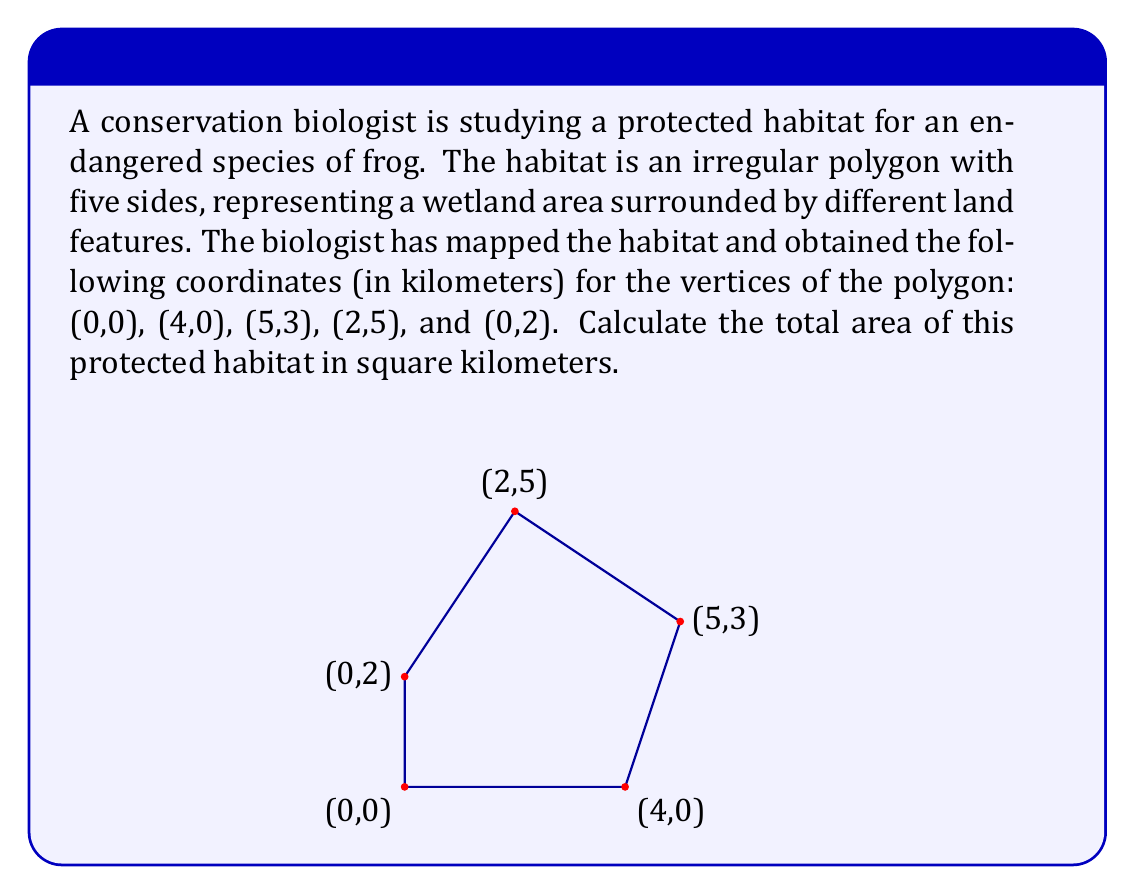What is the answer to this math problem? To calculate the area of this irregular polygon, we can use the Shoelace formula (also known as the surveyor's formula). This method is particularly useful for calculating the area of any polygon given the coordinates of its vertices.

The Shoelace formula is:

$$ A = \frac{1}{2}|\sum_{i=1}^{n-1} (x_iy_{i+1} + x_ny_1) - \sum_{i=1}^{n-1} (y_ix_{i+1} + y_nx_1)| $$

Where $(x_i, y_i)$ are the coordinates of the $i$-th vertex, and $n$ is the number of vertices.

Let's apply this formula to our polygon:

1) First, let's list our coordinates in order:
   $(x_1, y_1) = (0, 0)$
   $(x_2, y_2) = (4, 0)$
   $(x_3, y_3) = (5, 3)$
   $(x_4, y_4) = (2, 5)$
   $(x_5, y_5) = (0, 2)$

2) Now, let's calculate the first sum:
   $\sum_{i=1}^{n-1} (x_iy_{i+1} + x_ny_1) = (0 \cdot 0) + (4 \cdot 3) + (5 \cdot 5) + (2 \cdot 2) + (0 \cdot 0) = 12 + 25 + 4 = 41$

3) Then, the second sum:
   $\sum_{i=1}^{n-1} (y_ix_{i+1} + y_nx_1) = (0 \cdot 4) + (0 \cdot 5) + (3 \cdot 2) + (5 \cdot 0) + (2 \cdot 0) = 6$

4) Now, we can plug these into our formula:

   $$ A = \frac{1}{2}|41 - 6| = \frac{1}{2}(35) = 17.5 $$

Therefore, the area of the protected habitat is 17.5 square kilometers.
Answer: The area of the protected habitat is 17.5 square kilometers. 